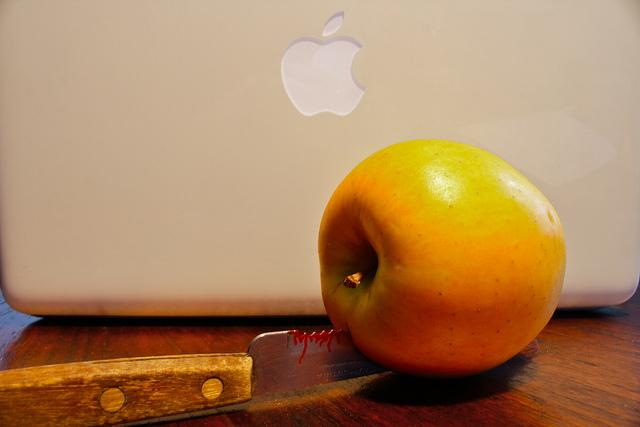What is likely the red substance on the knife? apple 